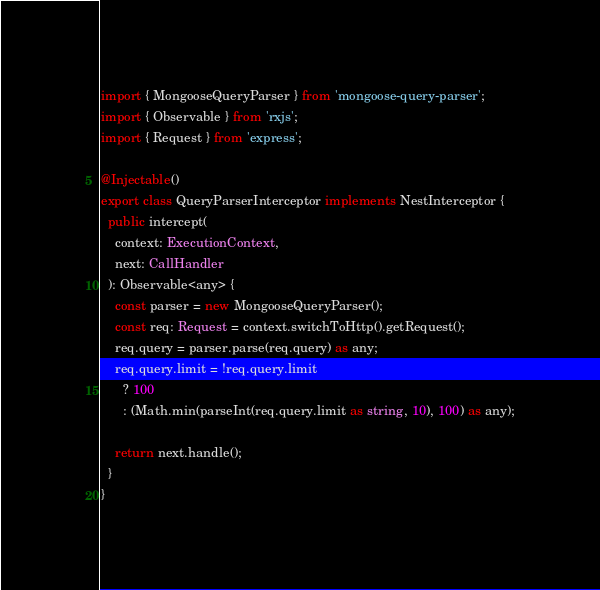<code> <loc_0><loc_0><loc_500><loc_500><_TypeScript_>import { MongooseQueryParser } from 'mongoose-query-parser';
import { Observable } from 'rxjs';
import { Request } from 'express';

@Injectable()
export class QueryParserInterceptor implements NestInterceptor {
  public intercept(
    context: ExecutionContext,
    next: CallHandler
  ): Observable<any> {
    const parser = new MongooseQueryParser();
    const req: Request = context.switchToHttp().getRequest();
    req.query = parser.parse(req.query) as any;
    req.query.limit = !req.query.limit
      ? 100
      : (Math.min(parseInt(req.query.limit as string, 10), 100) as any);

    return next.handle();
  }
}
</code> 